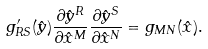<formula> <loc_0><loc_0><loc_500><loc_500>g ^ { \prime } _ { R S } ( \hat { y } ) \frac { \partial \hat { y } ^ { R } } { \partial \hat { x } ^ { M } } \frac { \partial \hat { y } ^ { S } } { \partial \hat { x } ^ { N } } = g _ { M N } ( \hat { x } ) .</formula> 